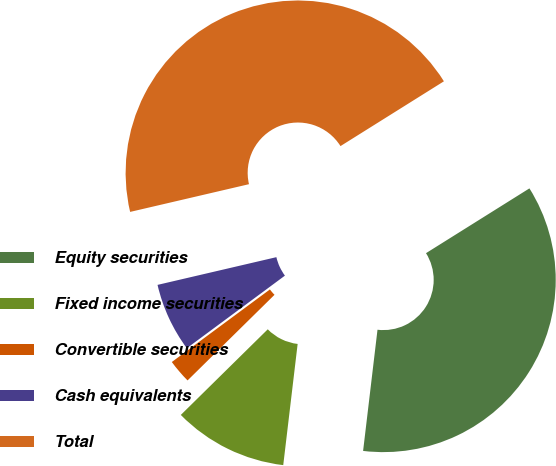<chart> <loc_0><loc_0><loc_500><loc_500><pie_chart><fcel>Equity securities<fcel>Fixed income securities<fcel>Convertible securities<fcel>Cash equivalents<fcel>Total<nl><fcel>35.79%<fcel>10.74%<fcel>2.24%<fcel>6.49%<fcel>44.74%<nl></chart> 